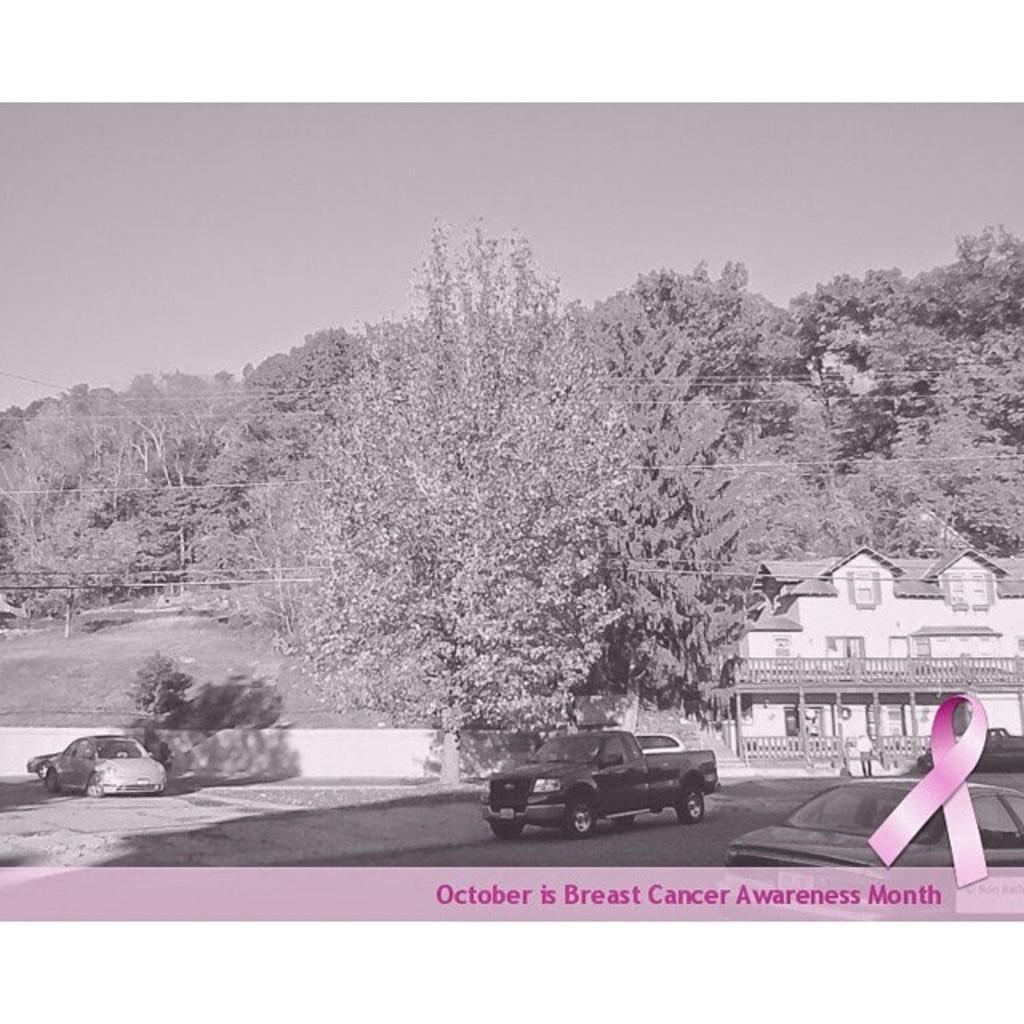Describe this image in one or two sentences. This is a black and white image. Here I can see few cars on the ground. On the right side there is a building. In the background there are many trees. At the top of the image I can see the sky. At the bottom of this image I can see some edited text and logo. 